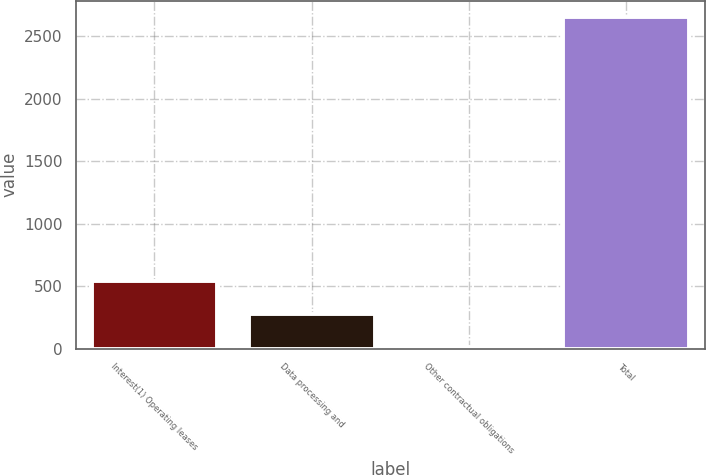Convert chart to OTSL. <chart><loc_0><loc_0><loc_500><loc_500><bar_chart><fcel>Interest(1) Operating leases<fcel>Data processing and<fcel>Other contractual obligations<fcel>Total<nl><fcel>538.22<fcel>274.41<fcel>10.6<fcel>2648.7<nl></chart> 